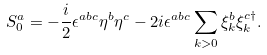Convert formula to latex. <formula><loc_0><loc_0><loc_500><loc_500>S _ { 0 } ^ { a } = - \frac { i } { 2 } \epsilon ^ { a b c } \eta ^ { b } \eta ^ { c } - 2 i \epsilon ^ { a b c } \sum _ { k > 0 } \xi _ { k } ^ { b } \xi _ { k } ^ { c \dagger } .</formula> 